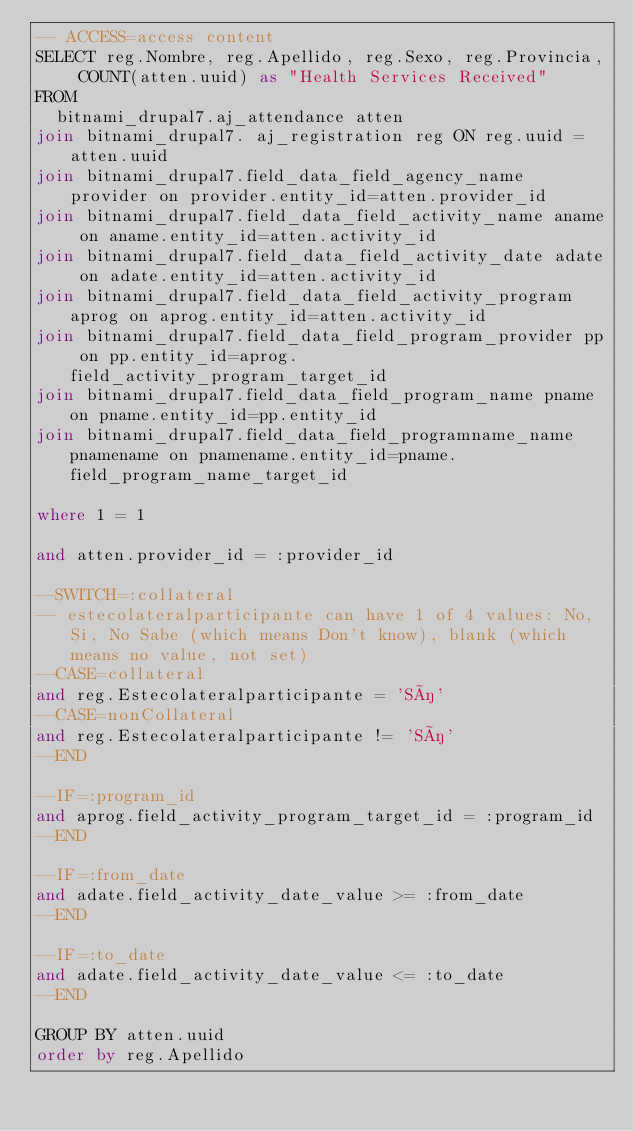Convert code to text. <code><loc_0><loc_0><loc_500><loc_500><_SQL_>-- ACCESS=access content
SELECT reg.Nombre, reg.Apellido, reg.Sexo, reg.Provincia, COUNT(atten.uuid) as "Health Services Received"
FROM
	bitnami_drupal7.aj_attendance atten 
join bitnami_drupal7. aj_registration reg ON reg.uuid = atten.uuid
join bitnami_drupal7.field_data_field_agency_name provider on provider.entity_id=atten.provider_id
join bitnami_drupal7.field_data_field_activity_name aname on aname.entity_id=atten.activity_id
join bitnami_drupal7.field_data_field_activity_date adate on adate.entity_id=atten.activity_id
join bitnami_drupal7.field_data_field_activity_program aprog on aprog.entity_id=atten.activity_id
join bitnami_drupal7.field_data_field_program_provider pp on pp.entity_id=aprog.field_activity_program_target_id
join bitnami_drupal7.field_data_field_program_name pname on pname.entity_id=pp.entity_id
join bitnami_drupal7.field_data_field_programname_name pnamename on pnamename.entity_id=pname.field_program_name_target_id

where 1 = 1 
 
and atten.provider_id = :provider_id

--SWITCH=:collateral
-- estecolateralparticipante can have 1 of 4 values: No, Si, No Sabe (which means Don't know), blank (which means no value, not set)
--CASE=collateral
and reg.Estecolateralparticipante = 'Sí'
--CASE=nonCollateral
and reg.Estecolateralparticipante != 'Sí'
--END

--IF=:program_id
and aprog.field_activity_program_target_id = :program_id  
--END

--IF=:from_date
and adate.field_activity_date_value >= :from_date
--END

--IF=:to_date
and adate.field_activity_date_value <= :to_date
--END

GROUP BY atten.uuid
order by reg.Apellido</code> 